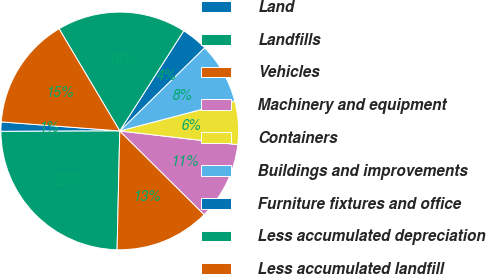Convert chart. <chart><loc_0><loc_0><loc_500><loc_500><pie_chart><fcel>Land<fcel>Landfills<fcel>Vehicles<fcel>Machinery and equipment<fcel>Containers<fcel>Buildings and improvements<fcel>Furniture fixtures and office<fcel>Less accumulated depreciation<fcel>Less accumulated landfill<nl><fcel>1.27%<fcel>24.58%<fcel>12.92%<fcel>10.59%<fcel>5.93%<fcel>8.26%<fcel>3.6%<fcel>17.58%<fcel>15.25%<nl></chart> 